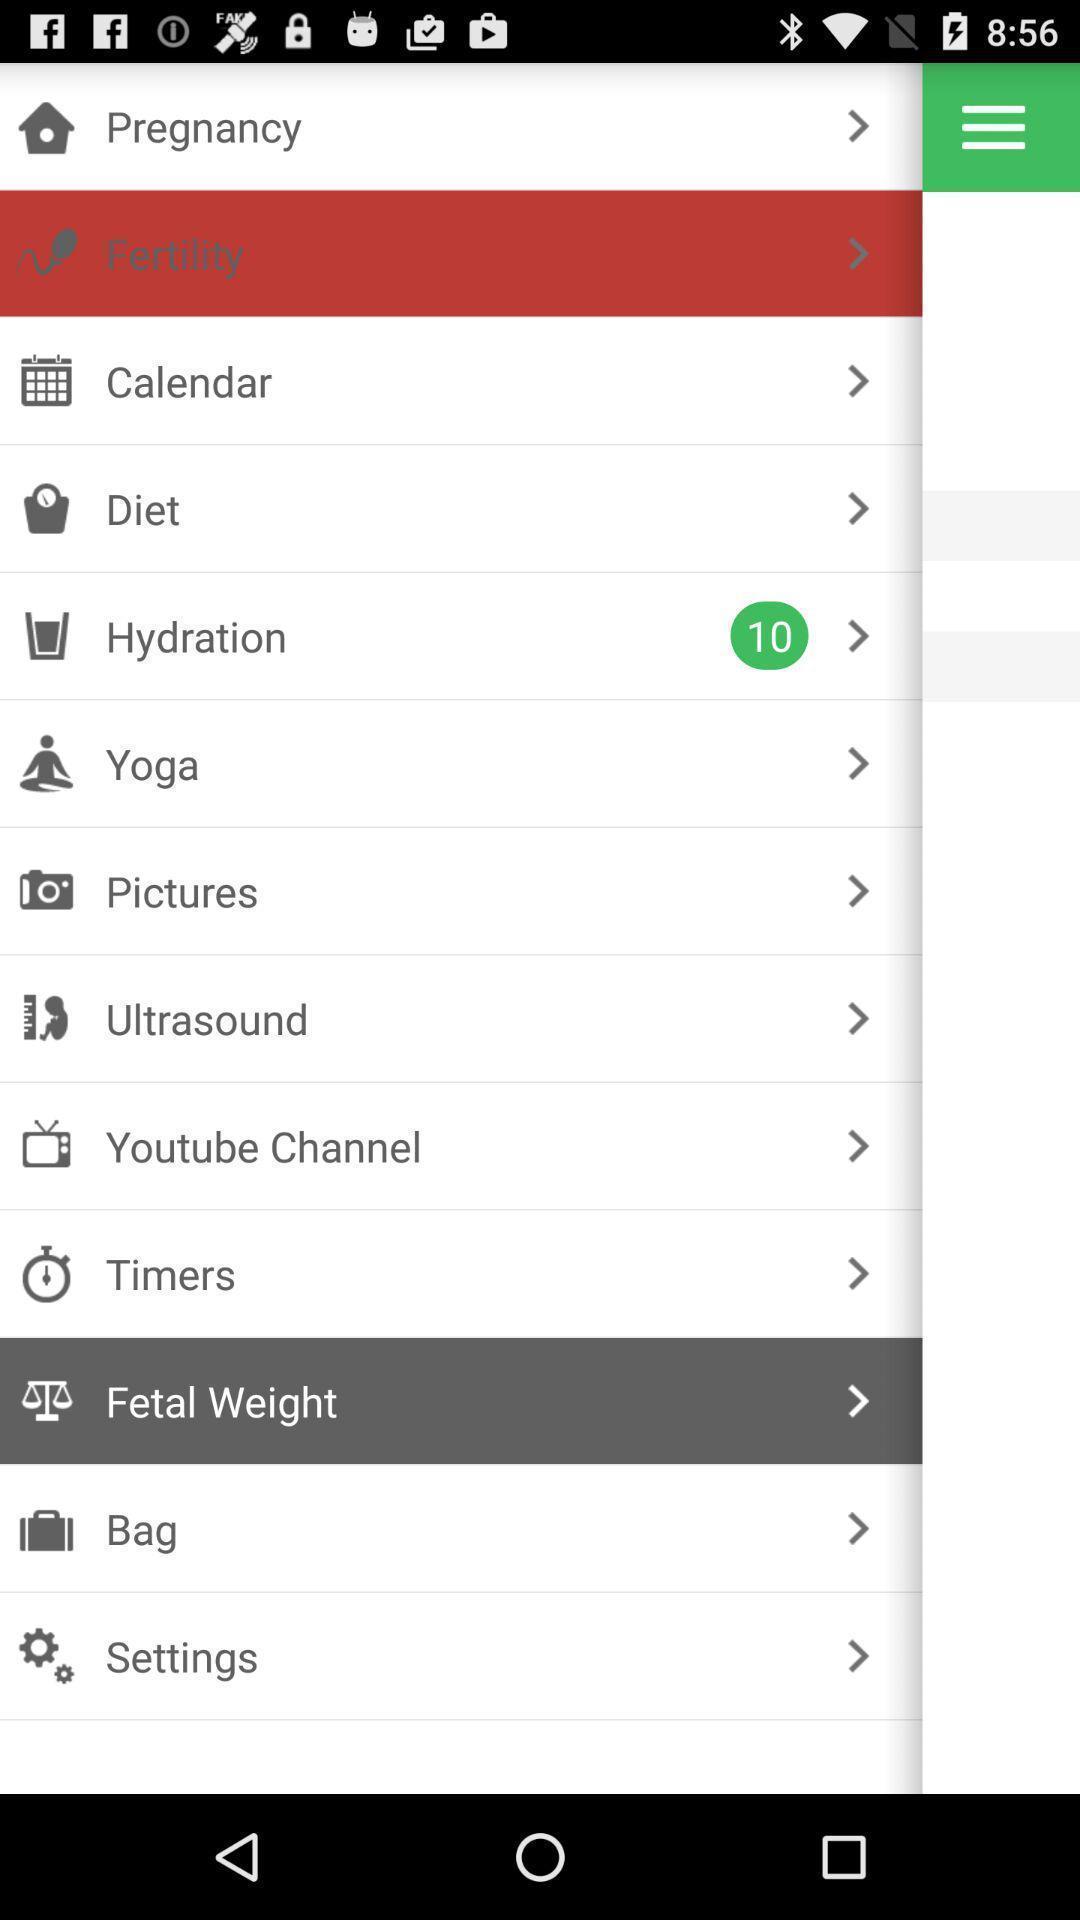Summarize the main components in this picture. Pop-up displaying the multiple features. 